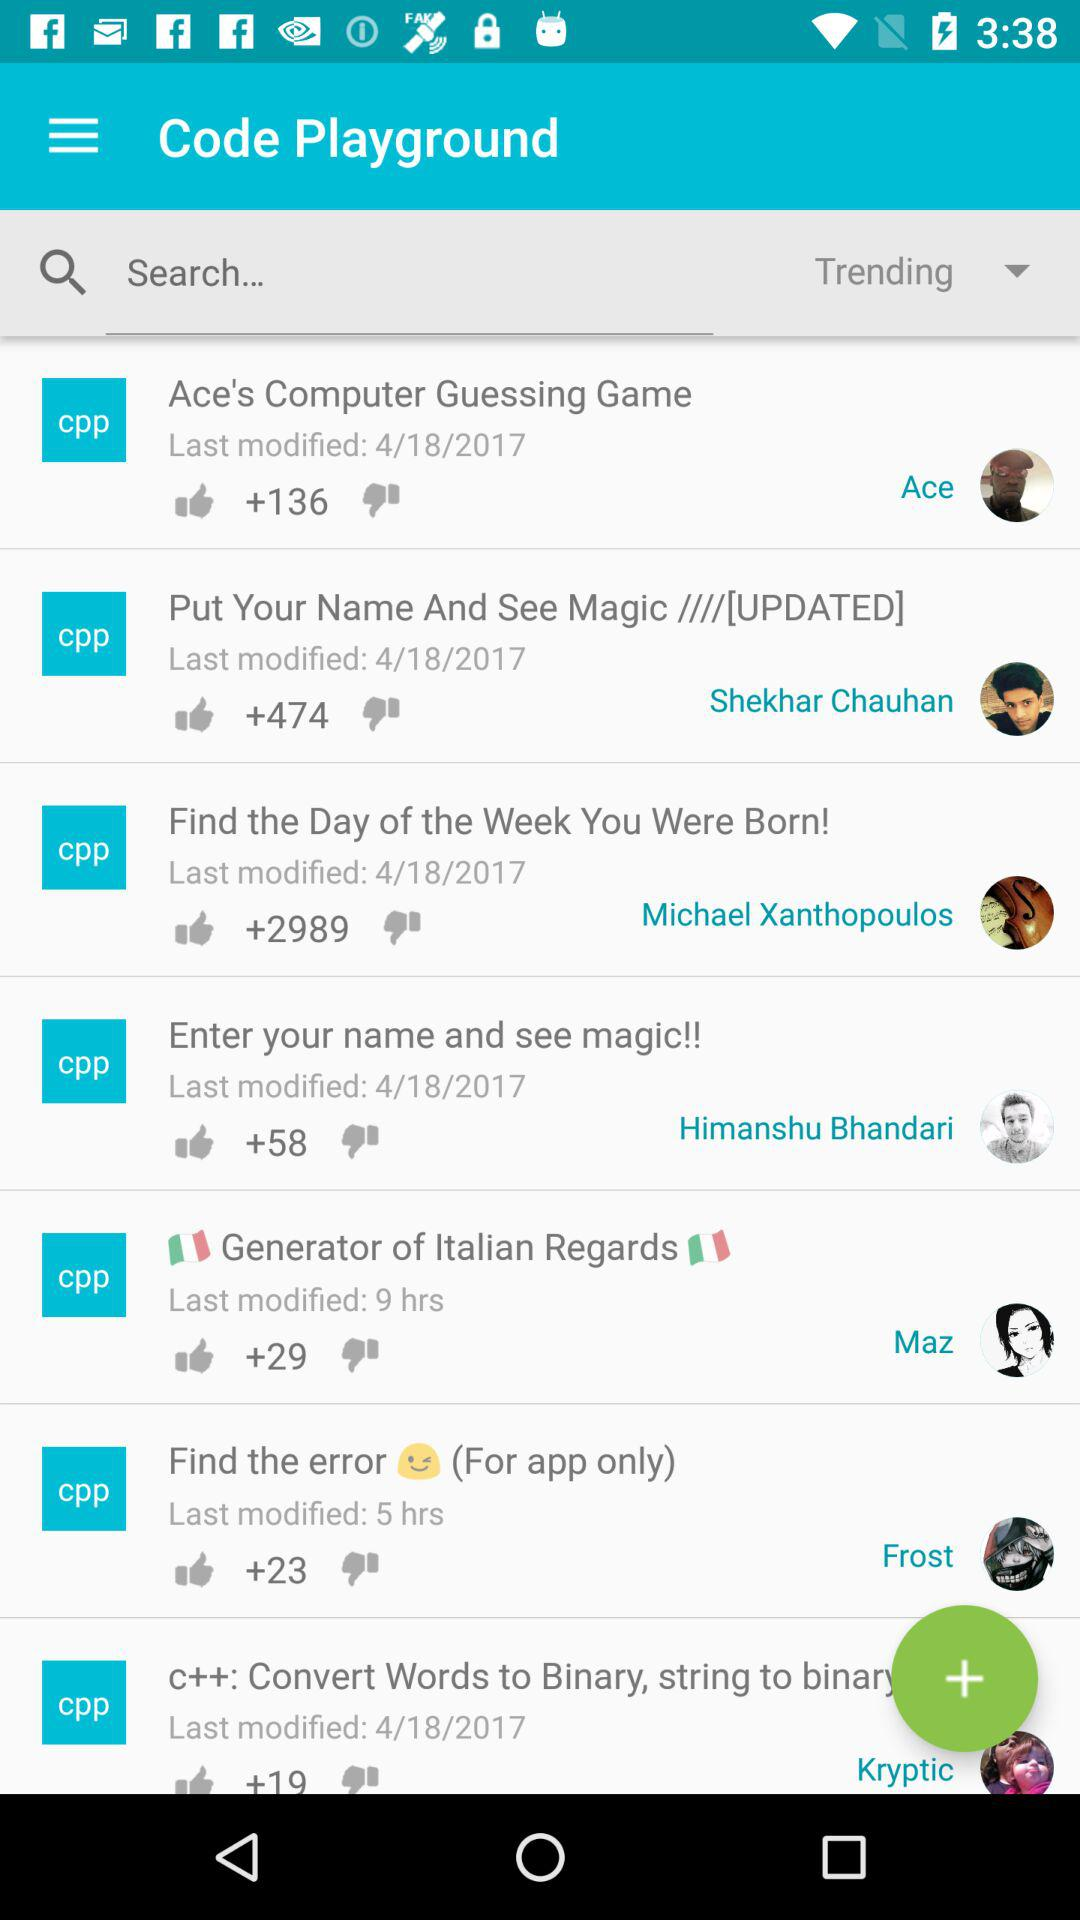How many thumbs up does the item with the most thumbs up have?
Answer the question using a single word or phrase. 2989 